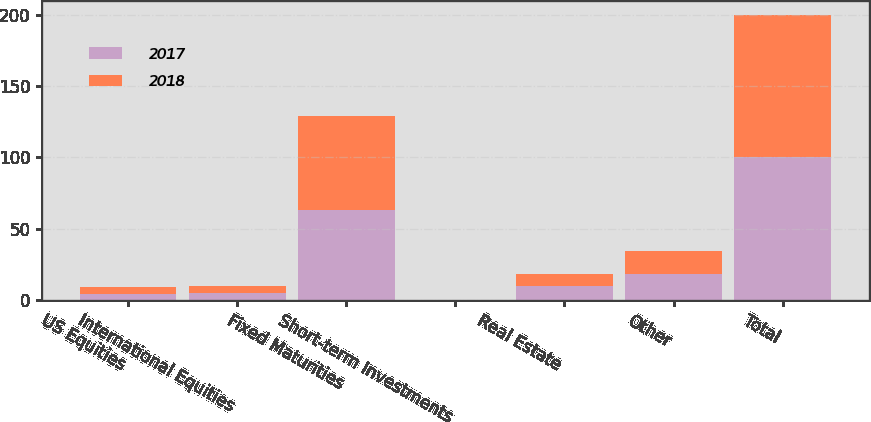Convert chart. <chart><loc_0><loc_0><loc_500><loc_500><stacked_bar_chart><ecel><fcel>US Equities<fcel>International Equities<fcel>Fixed Maturities<fcel>Short-term Investments<fcel>Real Estate<fcel>Other<fcel>Total<nl><fcel>2017<fcel>4<fcel>5<fcel>63<fcel>0<fcel>10<fcel>18<fcel>100<nl><fcel>2018<fcel>5<fcel>5<fcel>66<fcel>0<fcel>8<fcel>16<fcel>100<nl></chart> 